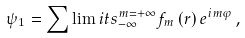<formula> <loc_0><loc_0><loc_500><loc_500>\psi _ { 1 } = \sum \lim i t s _ { - \infty } ^ { m = + \infty } f _ { m } \, ( r ) \, e ^ { i m \varphi } \, ,</formula> 